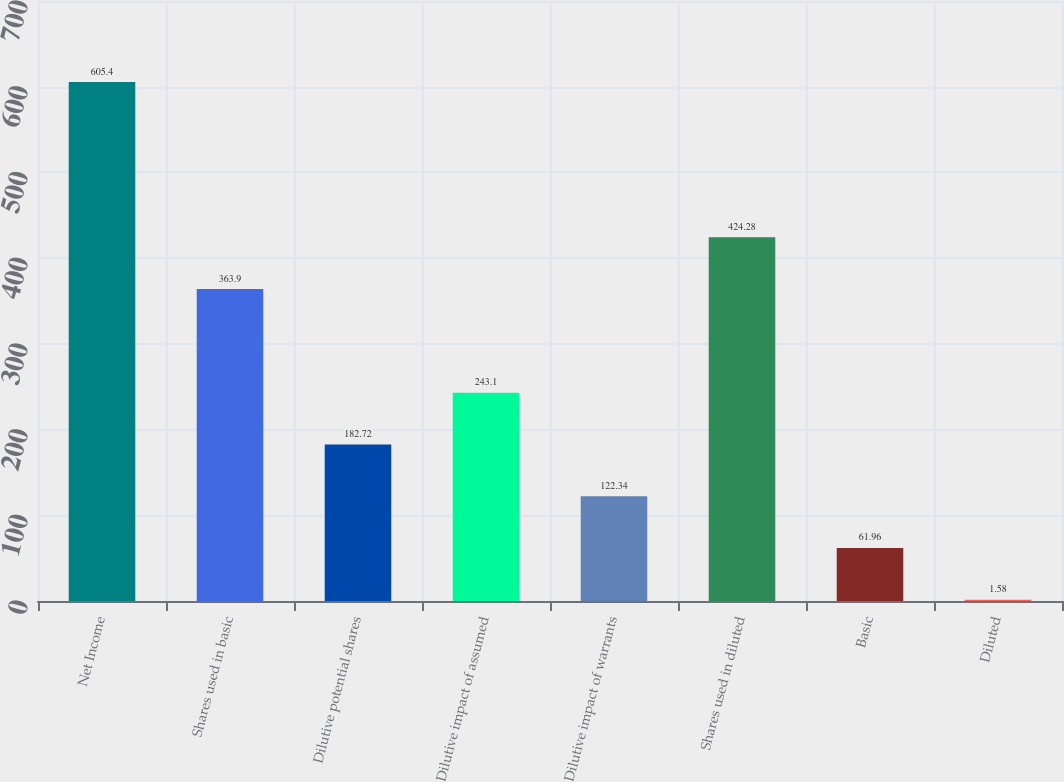Convert chart. <chart><loc_0><loc_0><loc_500><loc_500><bar_chart><fcel>Net Income<fcel>Shares used in basic<fcel>Dilutive potential shares<fcel>Dilutive impact of assumed<fcel>Dilutive impact of warrants<fcel>Shares used in diluted<fcel>Basic<fcel>Diluted<nl><fcel>605.4<fcel>363.9<fcel>182.72<fcel>243.1<fcel>122.34<fcel>424.28<fcel>61.96<fcel>1.58<nl></chart> 